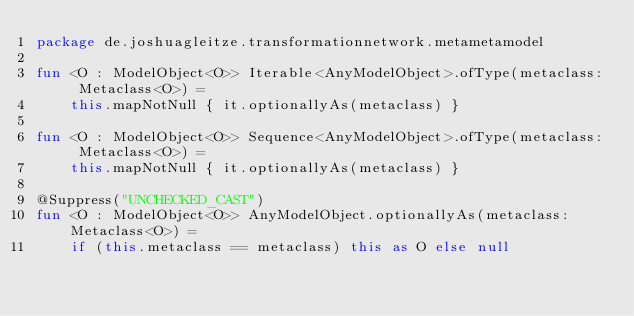Convert code to text. <code><loc_0><loc_0><loc_500><loc_500><_Kotlin_>package de.joshuagleitze.transformationnetwork.metametamodel

fun <O : ModelObject<O>> Iterable<AnyModelObject>.ofType(metaclass: Metaclass<O>) =
    this.mapNotNull { it.optionallyAs(metaclass) }

fun <O : ModelObject<O>> Sequence<AnyModelObject>.ofType(metaclass: Metaclass<O>) =
    this.mapNotNull { it.optionallyAs(metaclass) }

@Suppress("UNCHECKED_CAST")
fun <O : ModelObject<O>> AnyModelObject.optionallyAs(metaclass: Metaclass<O>) =
    if (this.metaclass == metaclass) this as O else null
</code> 